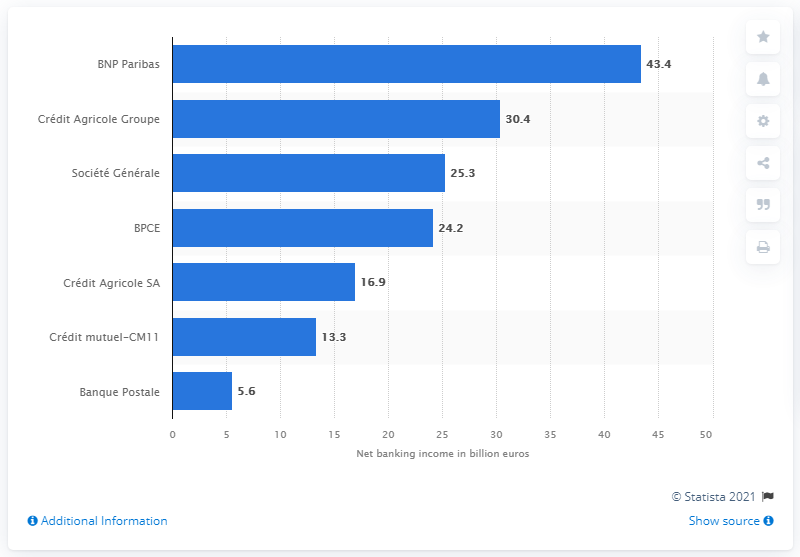What was the value of BNP Paribas's net income in 2016?
 43.4 